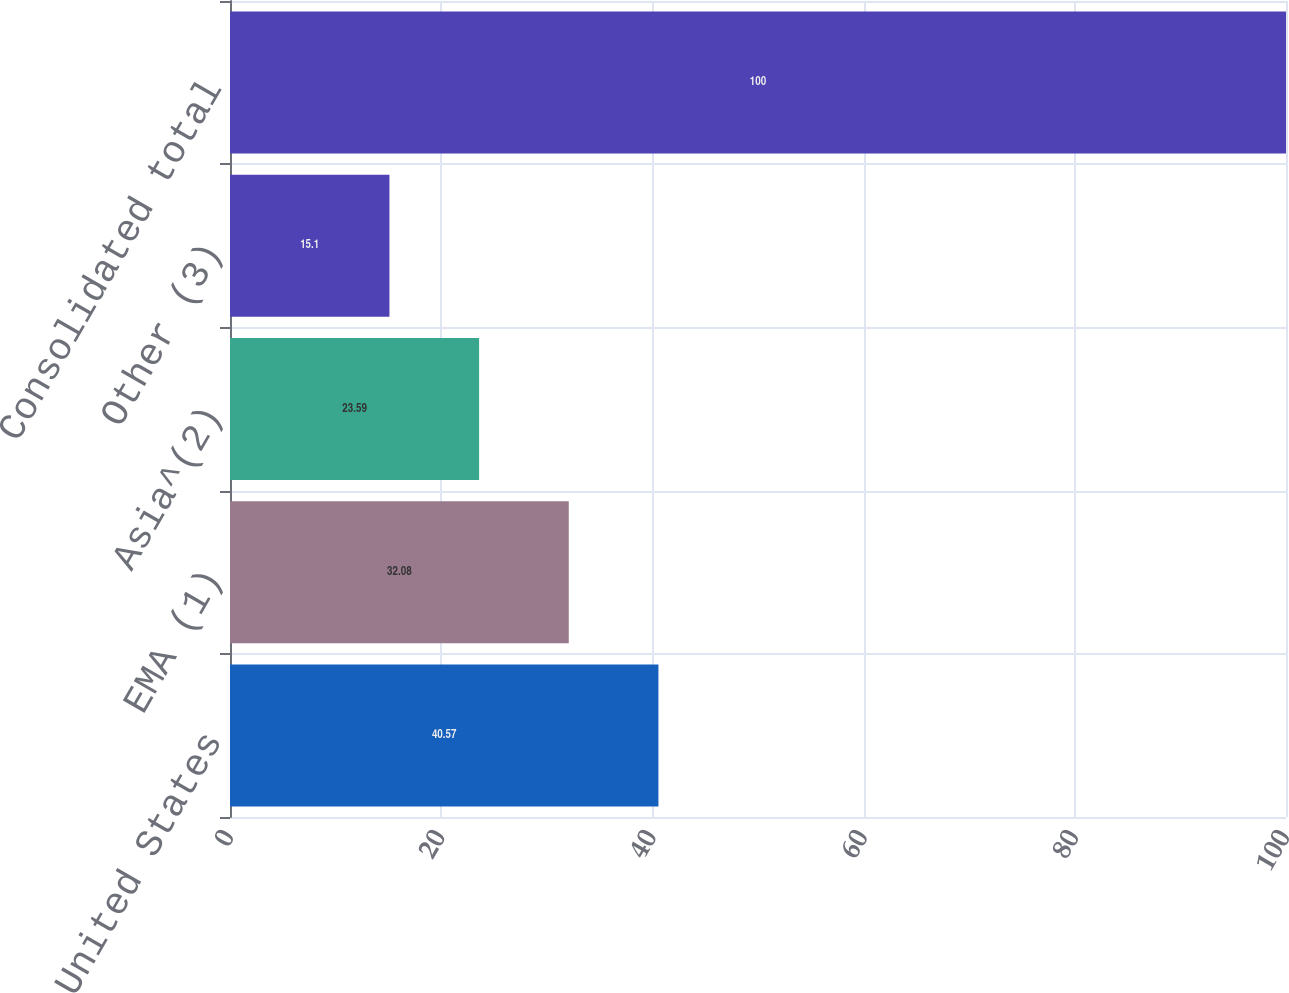Convert chart. <chart><loc_0><loc_0><loc_500><loc_500><bar_chart><fcel>United States<fcel>EMA (1)<fcel>Asia^(2)<fcel>Other (3)<fcel>Consolidated total<nl><fcel>40.57<fcel>32.08<fcel>23.59<fcel>15.1<fcel>100<nl></chart> 